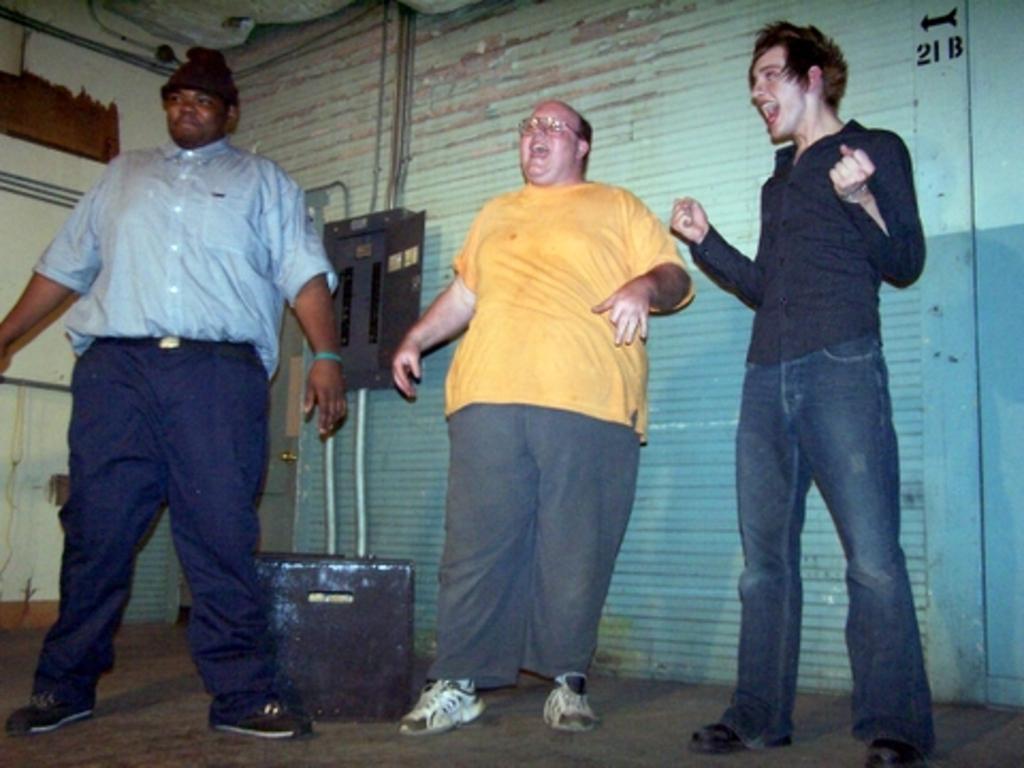Can you describe this image briefly? As we can see in the image there is a wall, rolling shutter and three people standing over here. 